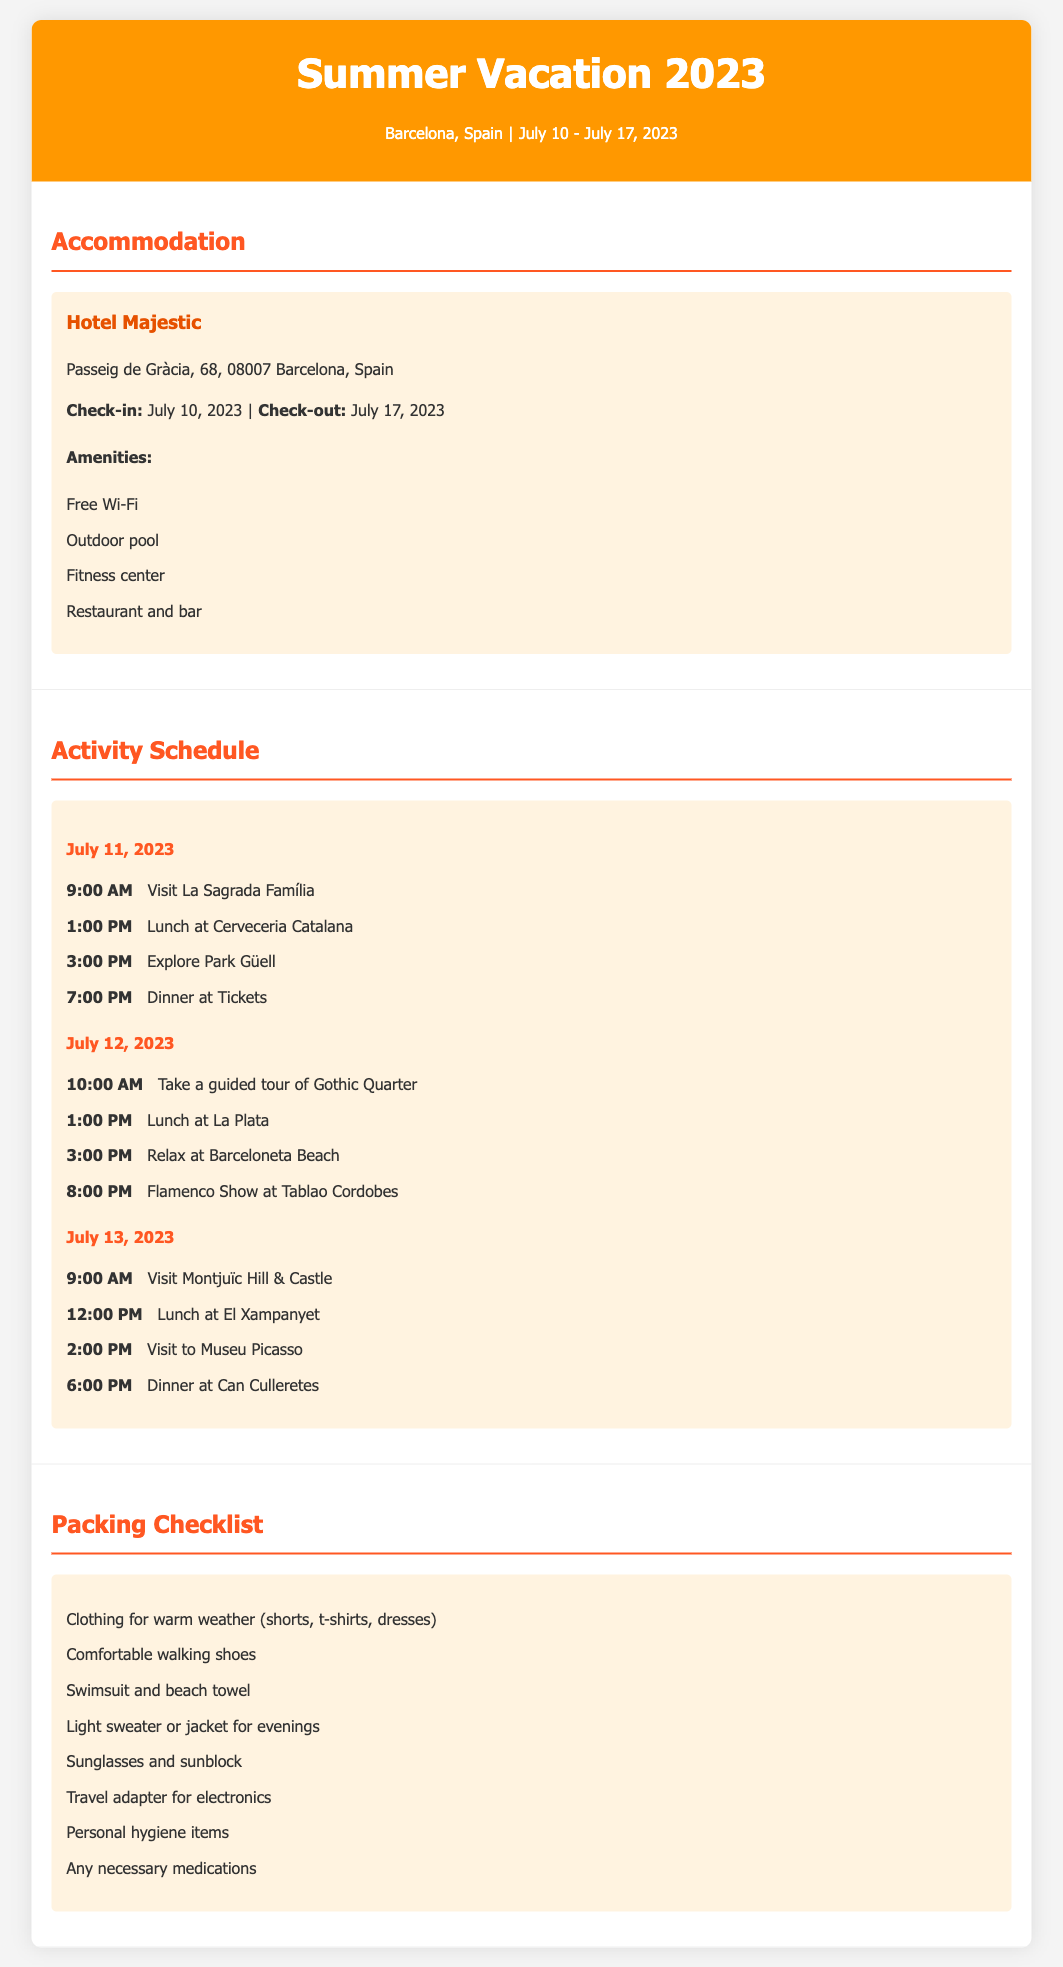What is the name of the hotel? The hotel mentioned in the document is Hotel Majestic located in Barcelona.
Answer: Hotel Majestic What is the address of the hotel? The address provided for the hotel in the document is Passeig de Gràcia, 68, 08007 Barcelona, Spain.
Answer: Passeig de Gràcia, 68, 08007 Barcelona, Spain What time is the visit to La Sagrada Família scheduled? The visit to La Sagrada Família is scheduled for 9:00 AM on July 11, 2023.
Answer: 9:00 AM How many activities are planned for July 12, 2023? The document lists four activities scheduled for July 12, 2023.
Answer: Four What is one of the meals mentioned in the activity schedule? The lunch at Cerveceria Catalana is one of the meals mentioned in the scheduled activities.
Answer: Lunch at Cerveceria Catalana Which activity takes place at 8:00 PM on July 12, 2023? The Flamenco Show at Tablao Cordobes is the activity taking place at 8:00 PM on that date.
Answer: Flamenco Show at Tablao Cordobes What item is on the packing checklist for sun protection? The packing checklist includes sunglasses and sunblock as items for sun protection.
Answer: Sunglasses and sunblock What type of shoes are recommended to pack? The packing checklist recommends bringing comfortable walking shoes for the trip.
Answer: Comfortable walking shoes 